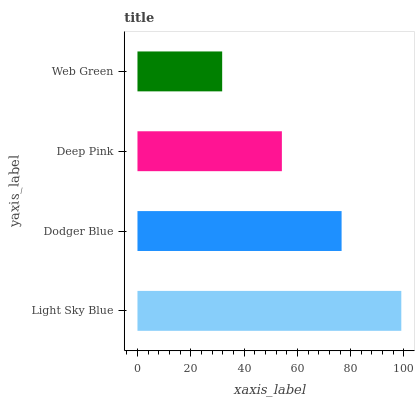Is Web Green the minimum?
Answer yes or no. Yes. Is Light Sky Blue the maximum?
Answer yes or no. Yes. Is Dodger Blue the minimum?
Answer yes or no. No. Is Dodger Blue the maximum?
Answer yes or no. No. Is Light Sky Blue greater than Dodger Blue?
Answer yes or no. Yes. Is Dodger Blue less than Light Sky Blue?
Answer yes or no. Yes. Is Dodger Blue greater than Light Sky Blue?
Answer yes or no. No. Is Light Sky Blue less than Dodger Blue?
Answer yes or no. No. Is Dodger Blue the high median?
Answer yes or no. Yes. Is Deep Pink the low median?
Answer yes or no. Yes. Is Light Sky Blue the high median?
Answer yes or no. No. Is Dodger Blue the low median?
Answer yes or no. No. 